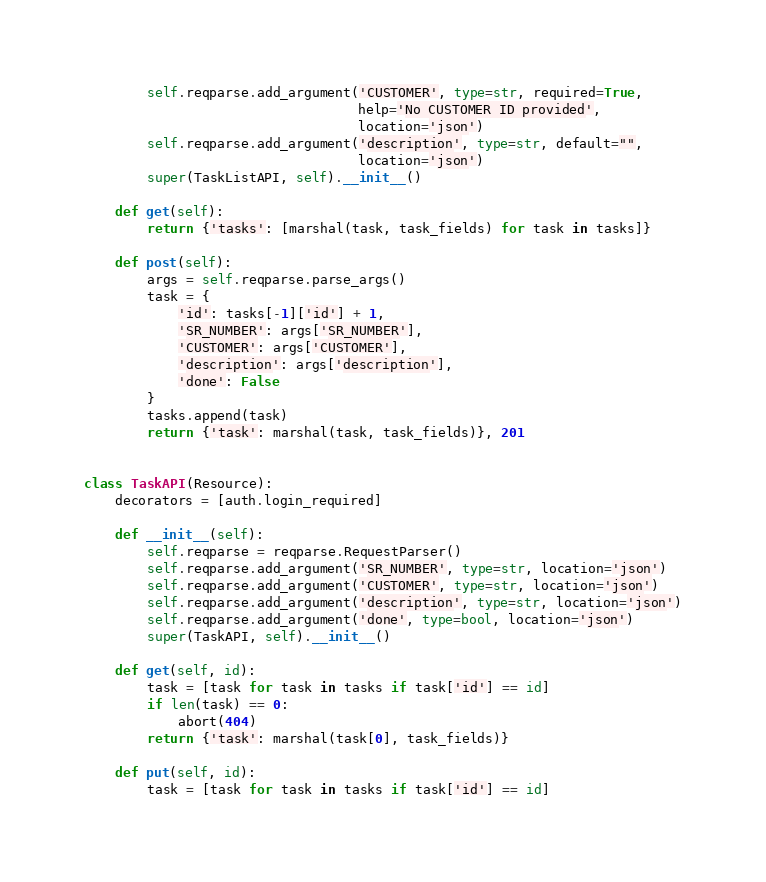Convert code to text. <code><loc_0><loc_0><loc_500><loc_500><_Python_>        self.reqparse.add_argument('CUSTOMER', type=str, required=True,
                                   help='No CUSTOMER ID provided',
                                   location='json')
        self.reqparse.add_argument('description', type=str, default="",
                                   location='json')
        super(TaskListAPI, self).__init__()

    def get(self):
        return {'tasks': [marshal(task, task_fields) for task in tasks]}

    def post(self):
        args = self.reqparse.parse_args()
        task = {
            'id': tasks[-1]['id'] + 1,
            'SR_NUMBER': args['SR_NUMBER'],
            'CUSTOMER': args['CUSTOMER'],
            'description': args['description'],
            'done': False
        }
        tasks.append(task)
        return {'task': marshal(task, task_fields)}, 201


class TaskAPI(Resource):
    decorators = [auth.login_required]

    def __init__(self):
        self.reqparse = reqparse.RequestParser()
        self.reqparse.add_argument('SR_NUMBER', type=str, location='json')
        self.reqparse.add_argument('CUSTOMER', type=str, location='json')
        self.reqparse.add_argument('description', type=str, location='json')
        self.reqparse.add_argument('done', type=bool, location='json')
        super(TaskAPI, self).__init__()

    def get(self, id):
        task = [task for task in tasks if task['id'] == id]
        if len(task) == 0:
            abort(404)
        return {'task': marshal(task[0], task_fields)}

    def put(self, id):
        task = [task for task in tasks if task['id'] == id]</code> 